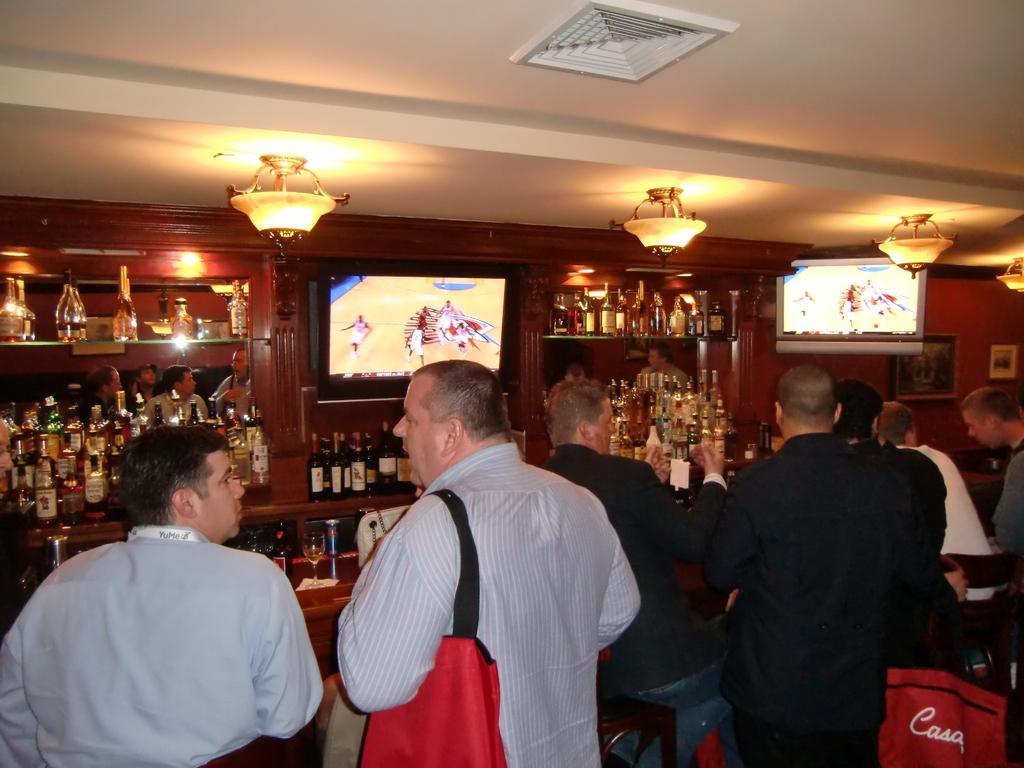Could you give a brief overview of what you see in this image? In this picture we can see some people standing in the front, in the background there are some racks, we can see wine bottles present on the racks, there are two screens here, we can see lights at the top of the picture, this man is carrying a bag. 